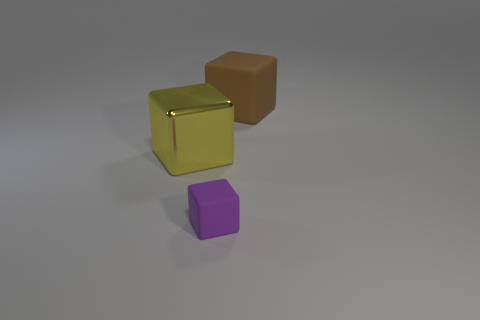Add 3 small purple rubber blocks. How many objects exist? 6 Add 3 blocks. How many blocks exist? 6 Subtract 0 purple balls. How many objects are left? 3 Subtract all large red cubes. Subtract all purple rubber things. How many objects are left? 2 Add 2 yellow objects. How many yellow objects are left? 3 